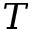Convert formula to latex. <formula><loc_0><loc_0><loc_500><loc_500>T</formula> 